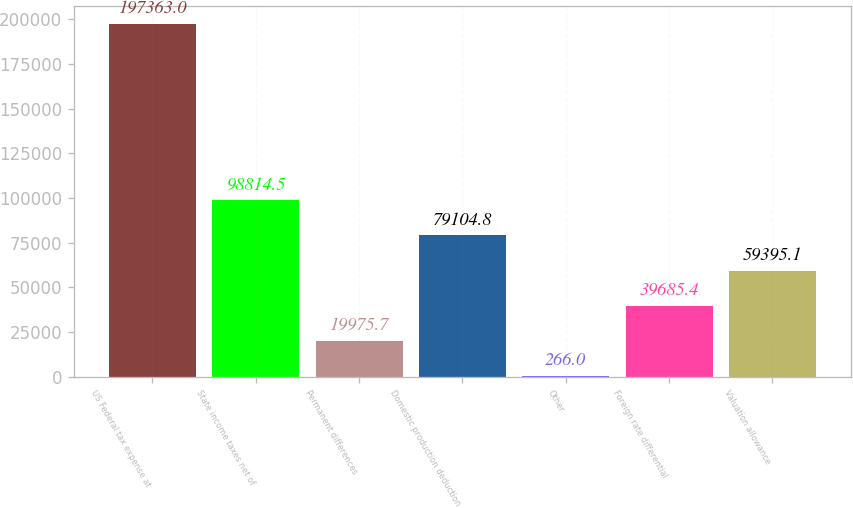Convert chart. <chart><loc_0><loc_0><loc_500><loc_500><bar_chart><fcel>US Federal tax expense at<fcel>State income taxes net of<fcel>Permanent differences<fcel>Domestic production deduction<fcel>Other<fcel>Foreign rate differential<fcel>Valuation allowance<nl><fcel>197363<fcel>98814.5<fcel>19975.7<fcel>79104.8<fcel>266<fcel>39685.4<fcel>59395.1<nl></chart> 